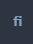<code> <loc_0><loc_0><loc_500><loc_500><_Bash_>fi
</code> 